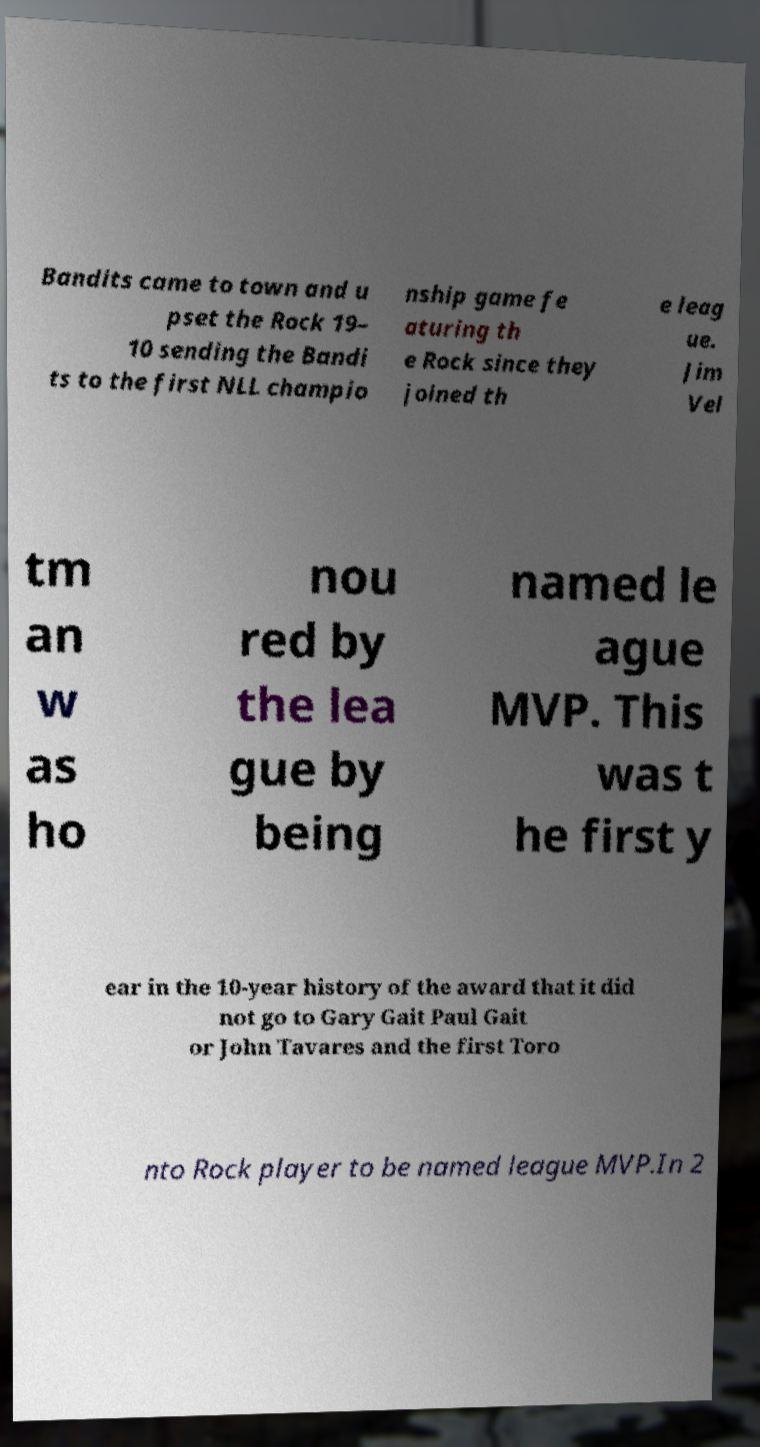I need the written content from this picture converted into text. Can you do that? Bandits came to town and u pset the Rock 19– 10 sending the Bandi ts to the first NLL champio nship game fe aturing th e Rock since they joined th e leag ue. Jim Vel tm an w as ho nou red by the lea gue by being named le ague MVP. This was t he first y ear in the 10-year history of the award that it did not go to Gary Gait Paul Gait or John Tavares and the first Toro nto Rock player to be named league MVP.In 2 